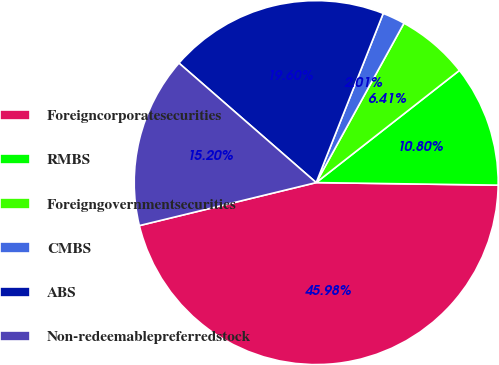Convert chart. <chart><loc_0><loc_0><loc_500><loc_500><pie_chart><fcel>Foreigncorporatesecurities<fcel>RMBS<fcel>Foreigngovernmentsecurities<fcel>CMBS<fcel>ABS<fcel>Non-redeemablepreferredstock<nl><fcel>45.98%<fcel>10.8%<fcel>6.41%<fcel>2.01%<fcel>19.6%<fcel>15.2%<nl></chart> 